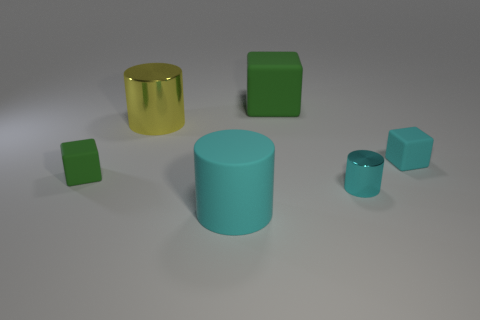Is there anything else of the same color as the matte cylinder?
Keep it short and to the point. Yes. Do the large metallic cylinder and the small matte cube that is to the right of the tiny green rubber object have the same color?
Ensure brevity in your answer.  No. Are there fewer rubber objects that are to the right of the cyan metallic thing than large gray cubes?
Provide a succinct answer. No. What is the material of the block that is right of the big rubber block?
Ensure brevity in your answer.  Rubber. What number of other objects are there of the same size as the cyan matte block?
Give a very brief answer. 2. Do the yellow metal cylinder and the green cube on the left side of the big rubber cylinder have the same size?
Offer a very short reply. No. What is the shape of the metal thing that is right of the green object that is to the right of the big object in front of the tiny cyan shiny cylinder?
Offer a terse response. Cylinder. Is the number of tiny green metal balls less than the number of big cyan matte things?
Ensure brevity in your answer.  Yes. Are there any big shiny cylinders behind the yellow metallic thing?
Provide a succinct answer. No. The tiny thing that is to the right of the large matte cylinder and behind the tiny metallic cylinder has what shape?
Keep it short and to the point. Cube. 